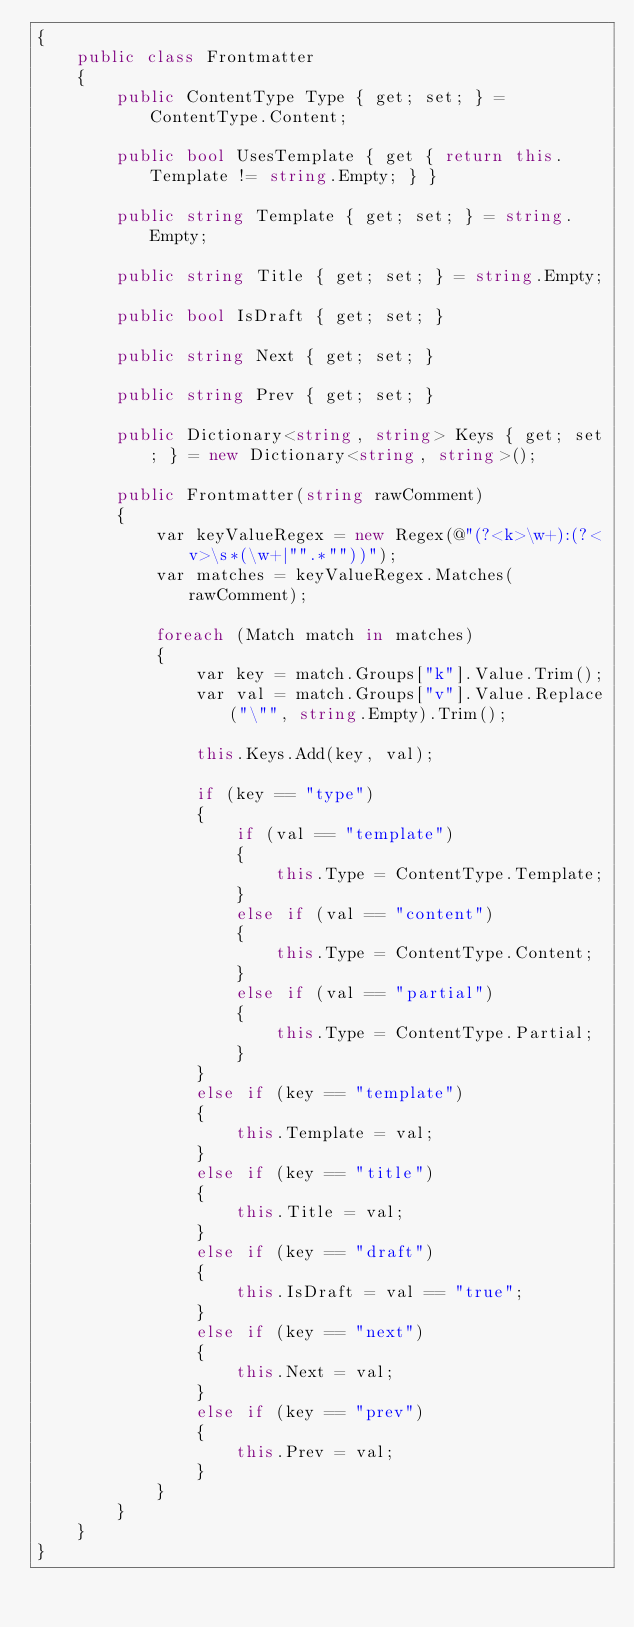Convert code to text. <code><loc_0><loc_0><loc_500><loc_500><_C#_>{
    public class Frontmatter
    {
        public ContentType Type { get; set; } = ContentType.Content;

        public bool UsesTemplate { get { return this.Template != string.Empty; } }

        public string Template { get; set; } = string.Empty;

        public string Title { get; set; } = string.Empty;

        public bool IsDraft { get; set; }

        public string Next { get; set; }

        public string Prev { get; set; }

        public Dictionary<string, string> Keys { get; set; } = new Dictionary<string, string>();

        public Frontmatter(string rawComment)
        {
            var keyValueRegex = new Regex(@"(?<k>\w+):(?<v>\s*(\w+|"".*""))");
            var matches = keyValueRegex.Matches(rawComment);

            foreach (Match match in matches)
            {
                var key = match.Groups["k"].Value.Trim();
                var val = match.Groups["v"].Value.Replace("\"", string.Empty).Trim();

                this.Keys.Add(key, val);

                if (key == "type")
                {
                    if (val == "template")
                    {
                        this.Type = ContentType.Template;
                    }
                    else if (val == "content")
                    {
                        this.Type = ContentType.Content;
                    }
                    else if (val == "partial")
                    {
                        this.Type = ContentType.Partial;
                    }
                }
                else if (key == "template")
                {
                    this.Template = val;
                }
                else if (key == "title")
                {
                    this.Title = val;
                }
                else if (key == "draft")
                {
                    this.IsDraft = val == "true";
                }
                else if (key == "next")
                {
                    this.Next = val;
                }
                else if (key == "prev")
                {
                    this.Prev = val;
                }
            }
        }
    }
}</code> 